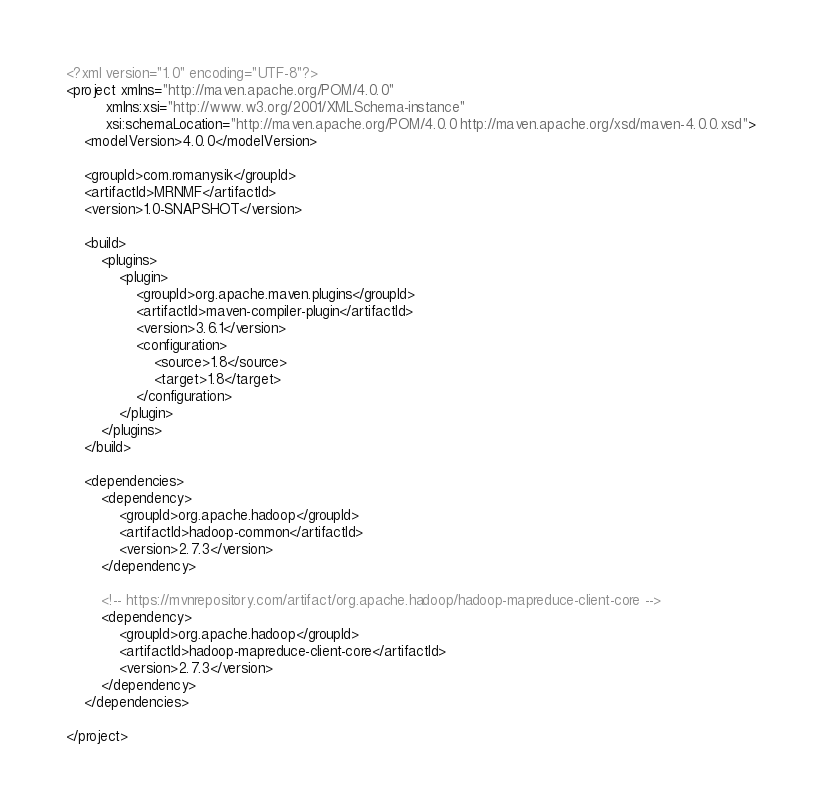Convert code to text. <code><loc_0><loc_0><loc_500><loc_500><_XML_><?xml version="1.0" encoding="UTF-8"?>
<project xmlns="http://maven.apache.org/POM/4.0.0"
         xmlns:xsi="http://www.w3.org/2001/XMLSchema-instance"
         xsi:schemaLocation="http://maven.apache.org/POM/4.0.0 http://maven.apache.org/xsd/maven-4.0.0.xsd">
    <modelVersion>4.0.0</modelVersion>

    <groupId>com.romanysik</groupId>
    <artifactId>MRNMF</artifactId>
    <version>1.0-SNAPSHOT</version>

    <build>
        <plugins>
            <plugin>
                <groupId>org.apache.maven.plugins</groupId>
                <artifactId>maven-compiler-plugin</artifactId>
                <version>3.6.1</version>
                <configuration>
                    <source>1.8</source>
                    <target>1.8</target>
                </configuration>
            </plugin>
        </plugins>
    </build>

    <dependencies>
        <dependency>
            <groupId>org.apache.hadoop</groupId>
            <artifactId>hadoop-common</artifactId>
            <version>2.7.3</version>
        </dependency>

        <!-- https://mvnrepository.com/artifact/org.apache.hadoop/hadoop-mapreduce-client-core -->
        <dependency>
            <groupId>org.apache.hadoop</groupId>
            <artifactId>hadoop-mapreduce-client-core</artifactId>
            <version>2.7.3</version>
        </dependency>
    </dependencies>

</project></code> 